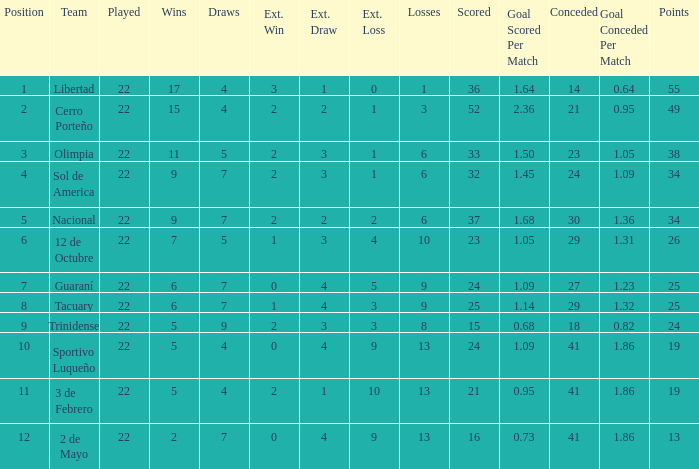What is the fewest wins that has fewer than 23 goals scored, team of 2 de Mayo, and fewer than 7 draws? None. 